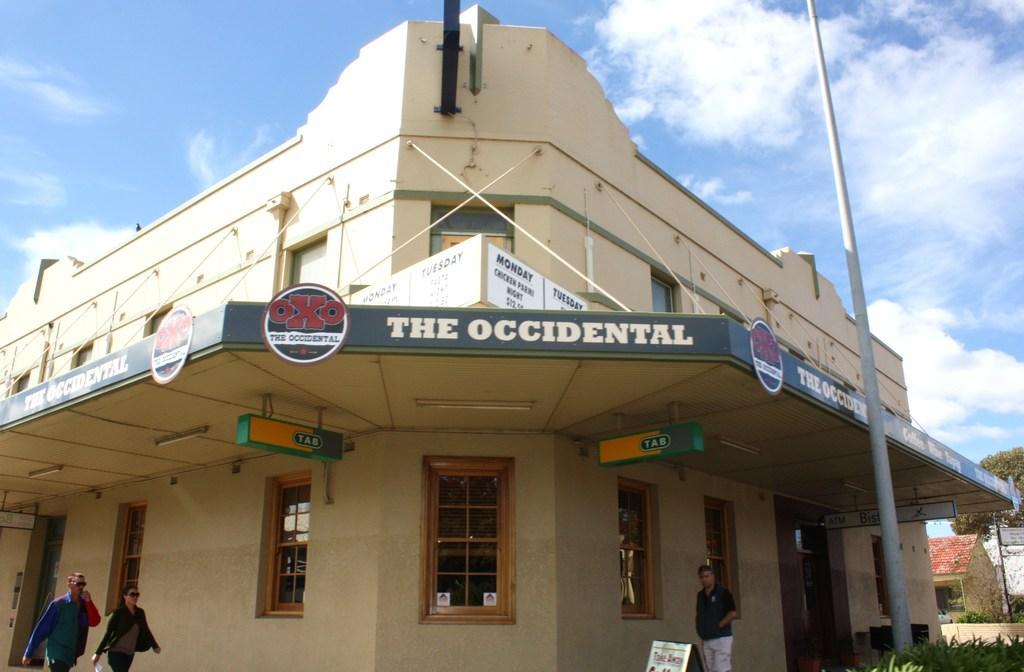Please provide a concise description of this image. This image consists of a building to which many boards are fixed. To the left, there are two persons walking. To the right, there is a man standing. To the top, there are clouds in the sky. 